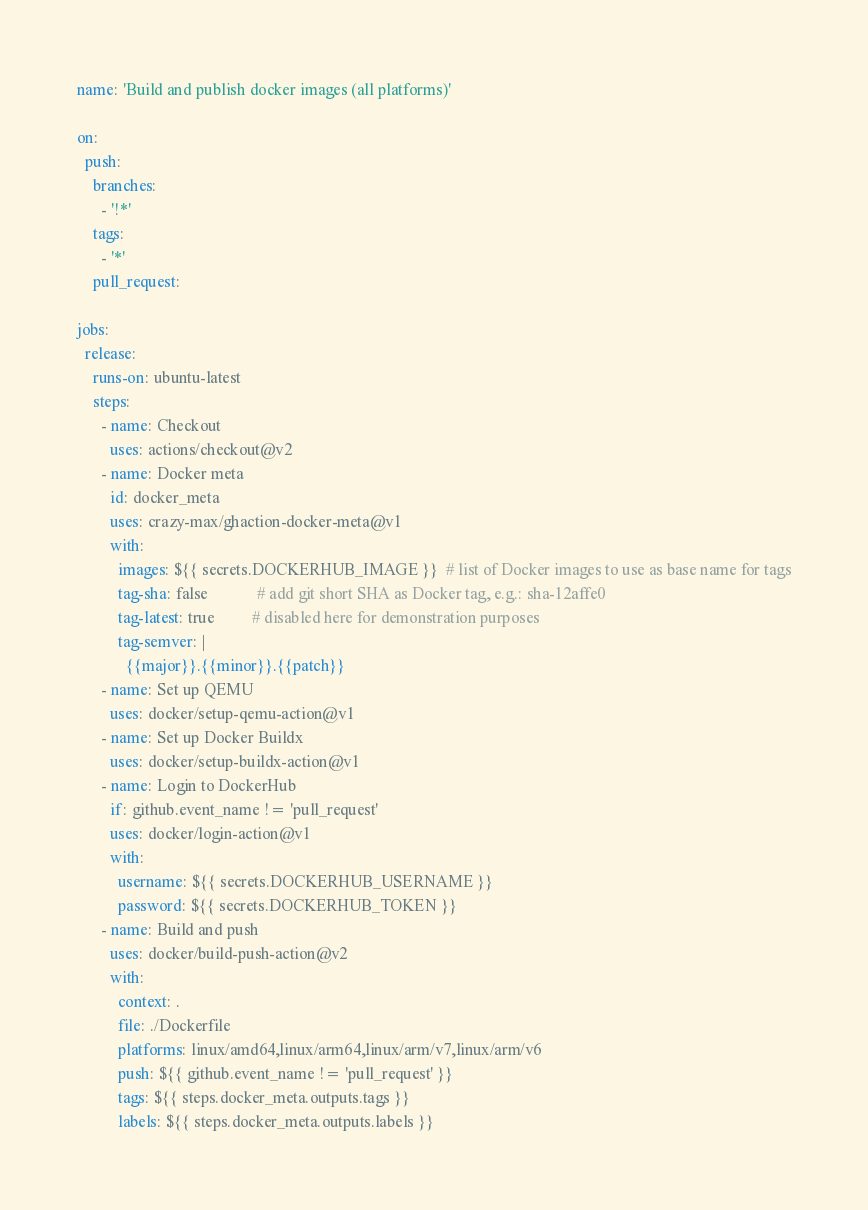<code> <loc_0><loc_0><loc_500><loc_500><_YAML_>name: 'Build and publish docker images (all platforms)'

on:
  push:
    branches:
      - '!*'
    tags:
      - '*'
    pull_request:

jobs:
  release:
    runs-on: ubuntu-latest
    steps:
      - name: Checkout
        uses: actions/checkout@v2
      - name: Docker meta
        id: docker_meta
        uses: crazy-max/ghaction-docker-meta@v1
        with:
          images: ${{ secrets.DOCKERHUB_IMAGE }}  # list of Docker images to use as base name for tags
          tag-sha: false            # add git short SHA as Docker tag, e.g.: sha-12affe0
          tag-latest: true         # disabled here for demonstration purposes
          tag-semver: | 
            {{major}}.{{minor}}.{{patch}}
      - name: Set up QEMU
        uses: docker/setup-qemu-action@v1
      - name: Set up Docker Buildx
        uses: docker/setup-buildx-action@v1
      - name: Login to DockerHub
        if: github.event_name != 'pull_request'
        uses: docker/login-action@v1
        with:
          username: ${{ secrets.DOCKERHUB_USERNAME }}
          password: ${{ secrets.DOCKERHUB_TOKEN }}
      - name: Build and push
        uses: docker/build-push-action@v2
        with:
          context: .
          file: ./Dockerfile
          platforms: linux/amd64,linux/arm64,linux/arm/v7,linux/arm/v6
          push: ${{ github.event_name != 'pull_request' }}
          tags: ${{ steps.docker_meta.outputs.tags }}
          labels: ${{ steps.docker_meta.outputs.labels }}
</code> 